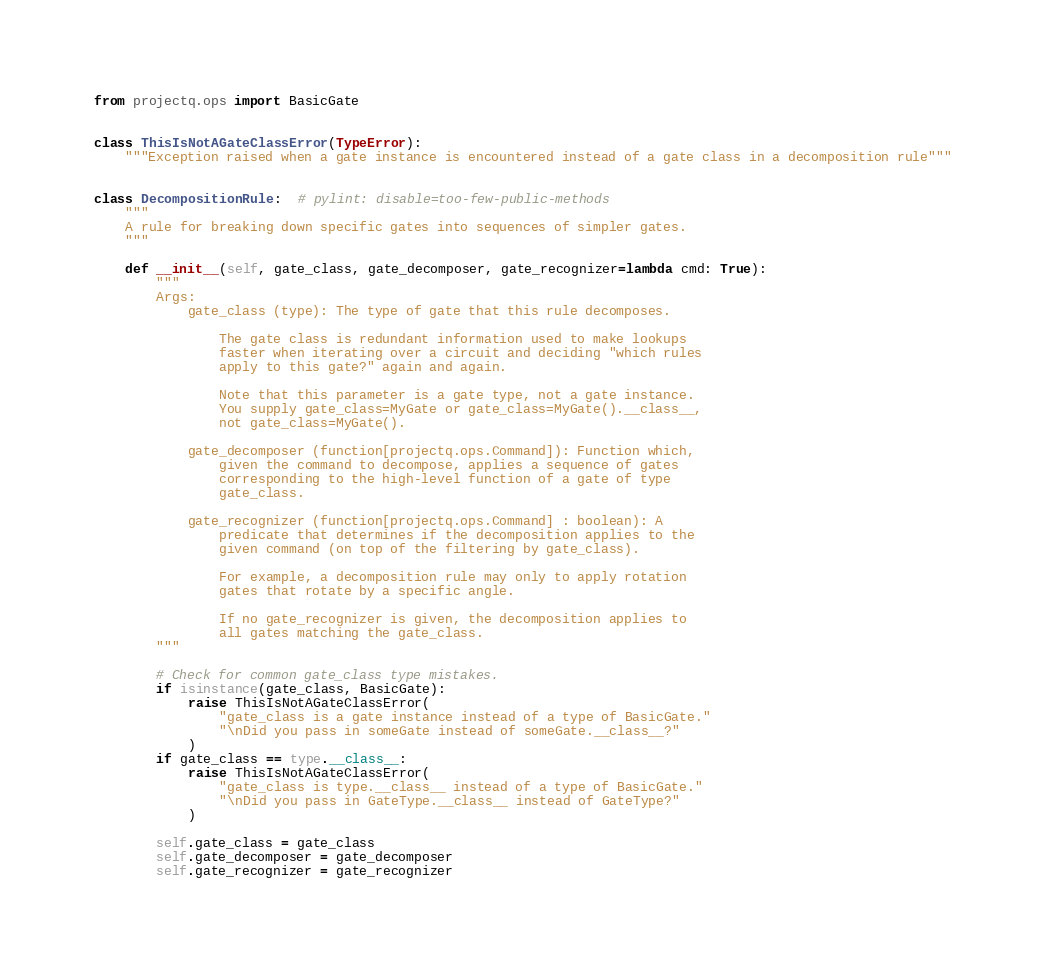Convert code to text. <code><loc_0><loc_0><loc_500><loc_500><_Python_>
from projectq.ops import BasicGate


class ThisIsNotAGateClassError(TypeError):
    """Exception raised when a gate instance is encountered instead of a gate class in a decomposition rule"""


class DecompositionRule:  # pylint: disable=too-few-public-methods
    """
    A rule for breaking down specific gates into sequences of simpler gates.
    """

    def __init__(self, gate_class, gate_decomposer, gate_recognizer=lambda cmd: True):
        """
        Args:
            gate_class (type): The type of gate that this rule decomposes.

                The gate class is redundant information used to make lookups
                faster when iterating over a circuit and deciding "which rules
                apply to this gate?" again and again.

                Note that this parameter is a gate type, not a gate instance.
                You supply gate_class=MyGate or gate_class=MyGate().__class__,
                not gate_class=MyGate().

            gate_decomposer (function[projectq.ops.Command]): Function which,
                given the command to decompose, applies a sequence of gates
                corresponding to the high-level function of a gate of type
                gate_class.

            gate_recognizer (function[projectq.ops.Command] : boolean): A
                predicate that determines if the decomposition applies to the
                given command (on top of the filtering by gate_class).

                For example, a decomposition rule may only to apply rotation
                gates that rotate by a specific angle.

                If no gate_recognizer is given, the decomposition applies to
                all gates matching the gate_class.
        """

        # Check for common gate_class type mistakes.
        if isinstance(gate_class, BasicGate):
            raise ThisIsNotAGateClassError(
                "gate_class is a gate instance instead of a type of BasicGate."
                "\nDid you pass in someGate instead of someGate.__class__?"
            )
        if gate_class == type.__class__:
            raise ThisIsNotAGateClassError(
                "gate_class is type.__class__ instead of a type of BasicGate."
                "\nDid you pass in GateType.__class__ instead of GateType?"
            )

        self.gate_class = gate_class
        self.gate_decomposer = gate_decomposer
        self.gate_recognizer = gate_recognizer
</code> 